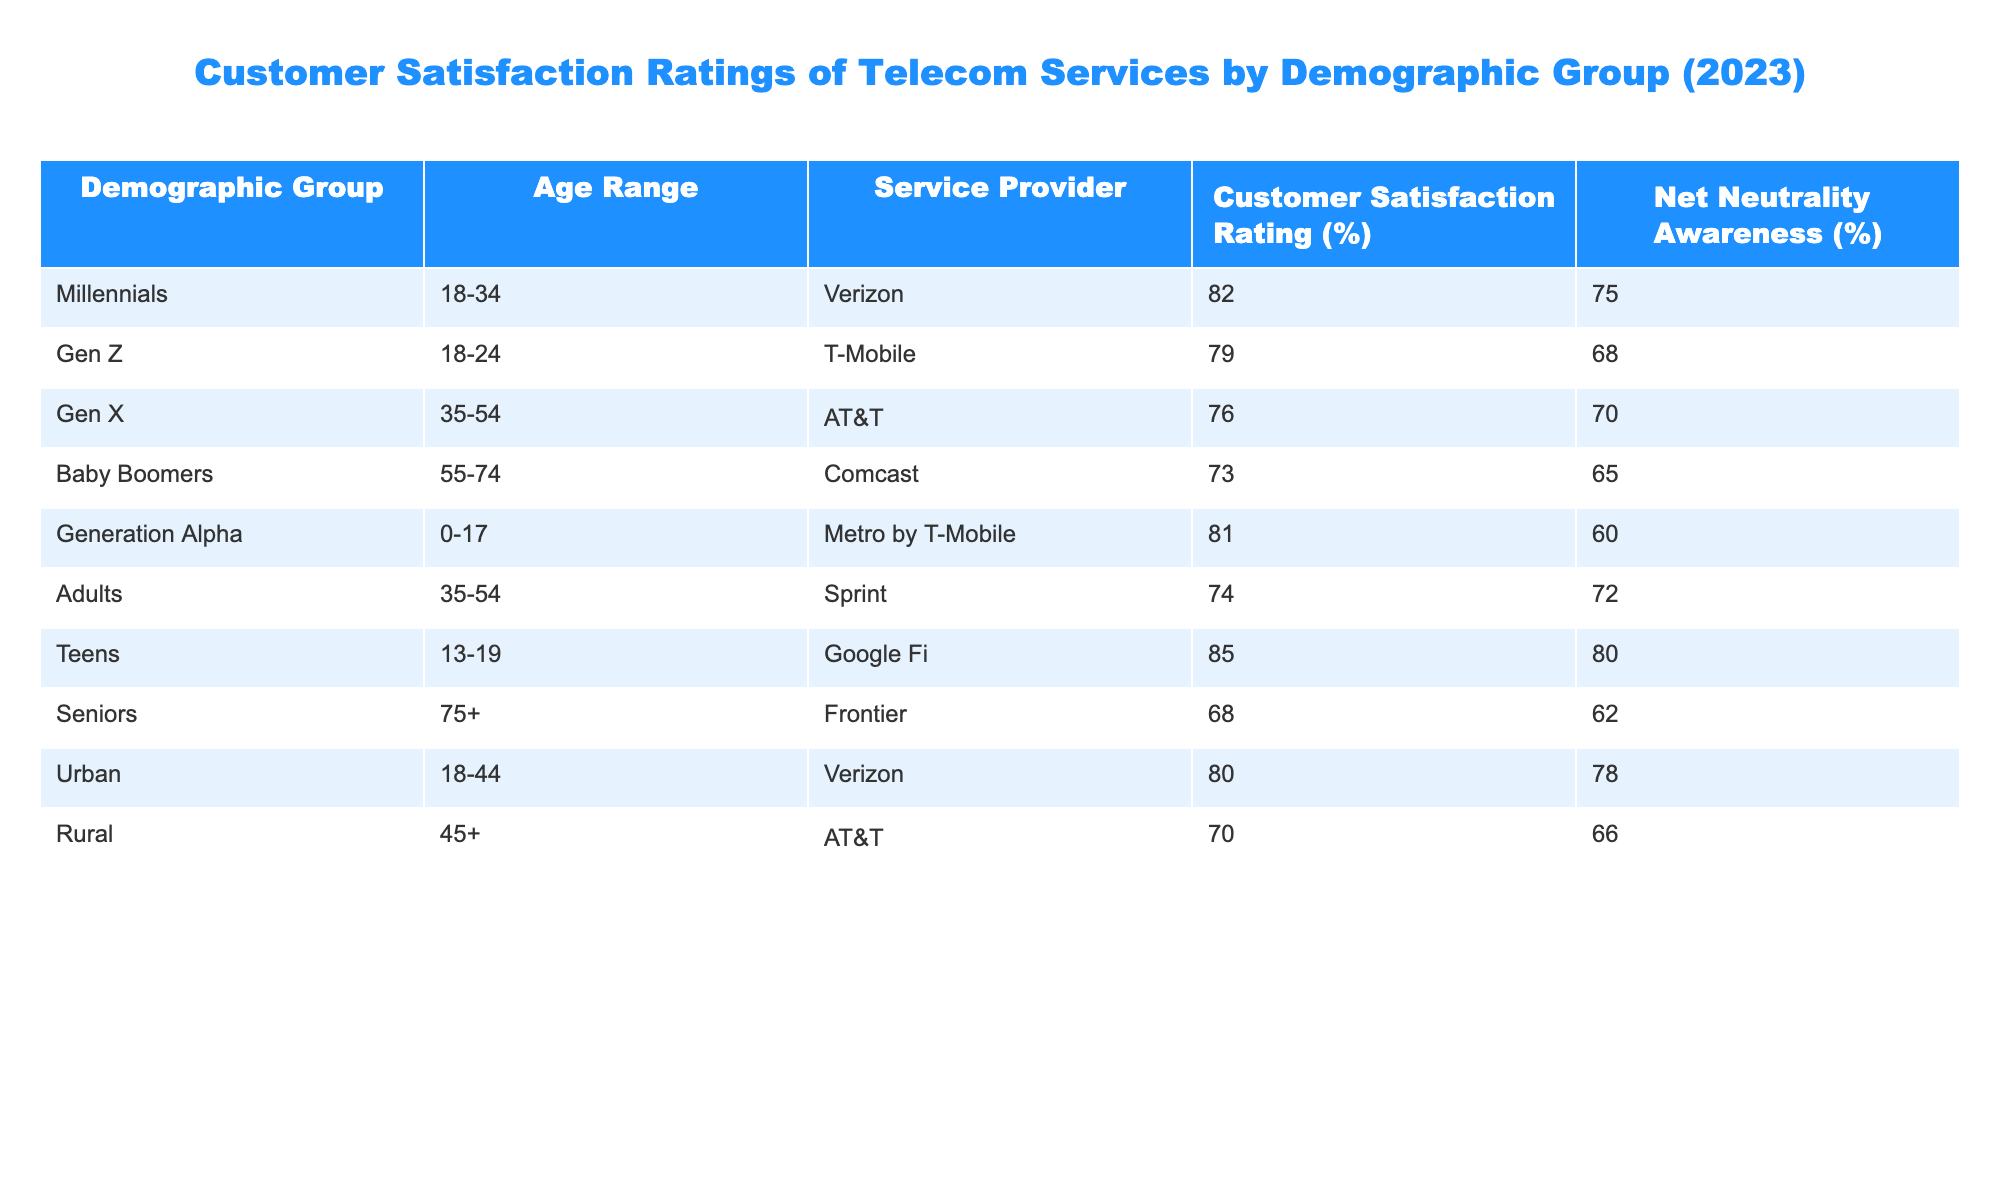What is the customer satisfaction rating for T-Mobile? The customer satisfaction rating for T-Mobile is listed in the table under the row corresponding to the Gen Z demographic group, which is 79%.
Answer: 79% Which service provider has the highest customer satisfaction rating? The table shows that Google Fi has the highest customer satisfaction rating at 85%, represented in the row for the Teens demographic group.
Answer: 85% Is the customer satisfaction rating for Baby Boomers higher than that for Seniors? The table shows that the customer satisfaction rating for Baby Boomers (73%) is indeed higher than that for Seniors (68%), so the answer is yes.
Answer: Yes What is the average customer satisfaction rating for the demographic groups aged 35-54? To find the average, we take the ratings for Gen X (76%) and Adults (74%), resulting in (76 + 74) / 2 = 75%.
Answer: 75% Which demographic group has the lowest awareness of net neutrality? The lowest awareness of net neutrality is found in the Baby Boomers group, with a percentage of 65% as seen in the corresponding row of the table.
Answer: 65% Calculate the difference in customer satisfaction ratings between Generation Alpha and Baby Boomers. The customer satisfaction rating for Generation Alpha is 81% and for Baby Boomers is 73%. The difference is 81 - 73 = 8%.
Answer: 8% True or False: Urban demographic group has a higher customer satisfaction rating than the Rural group. The table indicates that the Urban group has a rating of 80% while the Rural group's rating is 70%, confirming the statement as true.
Answer: True If we sum the customer satisfaction ratings for all demographic groups, what total do we get? Adding the ratings gives us: 82 + 79 + 76 + 73 + 81 + 74 + 85 + 68 + 80 + 70 =  818. Therefore, the total is 818.
Answer: 818 Which demographic group is the only one served by Sprint? According to the table, the Adults demographic group, specifically those aged 35-54, is the only group associated with Sprint.
Answer: Adults 